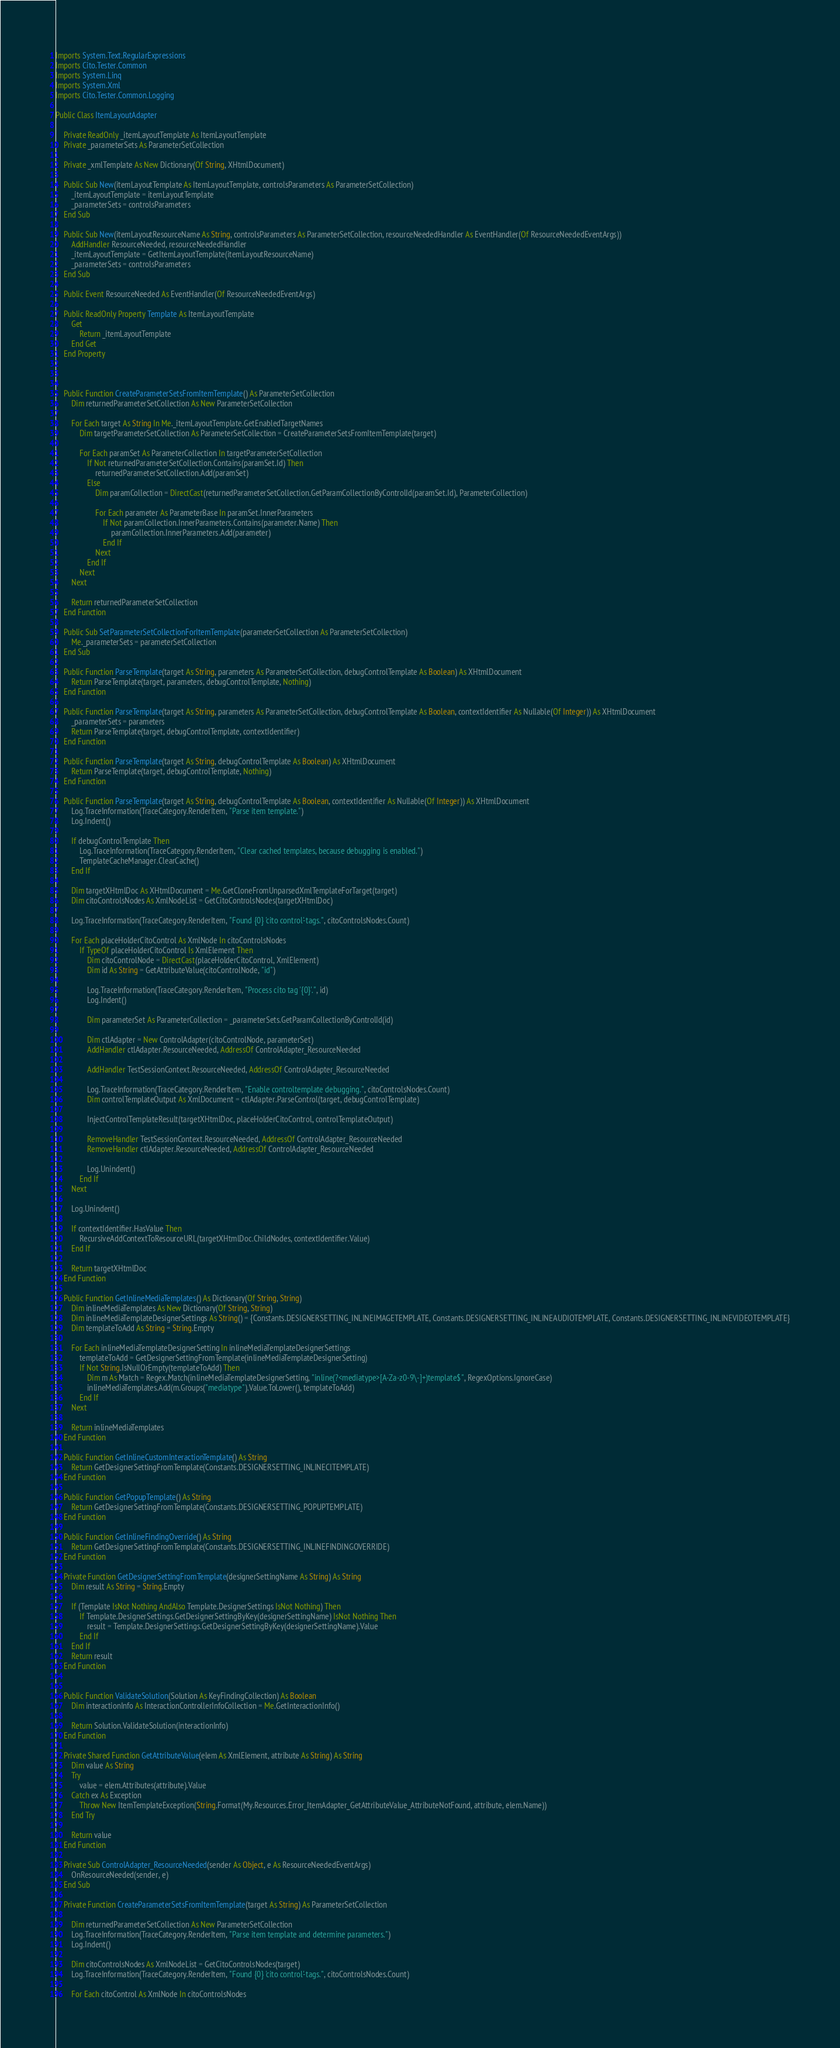Convert code to text. <code><loc_0><loc_0><loc_500><loc_500><_VisualBasic_>Imports System.Text.RegularExpressions
Imports Cito.Tester.Common
Imports System.Linq
Imports System.Xml
Imports Cito.Tester.Common.Logging

Public Class ItemLayoutAdapter

    Private ReadOnly _itemLayoutTemplate As ItemLayoutTemplate
    Private _parameterSets As ParameterSetCollection

    Private _xmlTemplate As New Dictionary(Of String, XHtmlDocument)

    Public Sub New(itemLayoutTemplate As ItemLayoutTemplate, controlsParameters As ParameterSetCollection)
        _itemLayoutTemplate = itemLayoutTemplate
        _parameterSets = controlsParameters
    End Sub

    Public Sub New(itemLayoutResourceName As String, controlsParameters As ParameterSetCollection, resourceNeededHandler As EventHandler(Of ResourceNeededEventArgs))
        AddHandler ResourceNeeded, resourceNeededHandler
        _itemLayoutTemplate = GetItemLayoutTemplate(itemLayoutResourceName)
        _parameterSets = controlsParameters
    End Sub

    Public Event ResourceNeeded As EventHandler(Of ResourceNeededEventArgs)

    Public ReadOnly Property Template As ItemLayoutTemplate
        Get
            Return _itemLayoutTemplate
        End Get
    End Property



    Public Function CreateParameterSetsFromItemTemplate() As ParameterSetCollection
        Dim returnedParameterSetCollection As New ParameterSetCollection

        For Each target As String In Me._itemLayoutTemplate.GetEnabledTargetNames
            Dim targetParameterSetCollection As ParameterSetCollection = CreateParameterSetsFromItemTemplate(target)

            For Each paramSet As ParameterCollection In targetParameterSetCollection
                If Not returnedParameterSetCollection.Contains(paramSet.Id) Then
                    returnedParameterSetCollection.Add(paramSet)
                Else
                    Dim paramCollection = DirectCast(returnedParameterSetCollection.GetParamCollectionByControlId(paramSet.Id), ParameterCollection)

                    For Each parameter As ParameterBase In paramSet.InnerParameters
                        If Not paramCollection.InnerParameters.Contains(parameter.Name) Then
                            paramCollection.InnerParameters.Add(parameter)
                        End If
                    Next
                End If
            Next
        Next

        Return returnedParameterSetCollection
    End Function

    Public Sub SetParameterSetCollectionForItemTemplate(parameterSetCollection As ParameterSetCollection)
        Me._parameterSets = parameterSetCollection
    End Sub

    Public Function ParseTemplate(target As String, parameters As ParameterSetCollection, debugControlTemplate As Boolean) As XHtmlDocument
        Return ParseTemplate(target, parameters, debugControlTemplate, Nothing)
    End Function

    Public Function ParseTemplate(target As String, parameters As ParameterSetCollection, debugControlTemplate As Boolean, contextIdentifier As Nullable(Of Integer)) As XHtmlDocument
        _parameterSets = parameters
        Return ParseTemplate(target, debugControlTemplate, contextIdentifier)
    End Function

    Public Function ParseTemplate(target As String, debugControlTemplate As Boolean) As XHtmlDocument
        Return ParseTemplate(target, debugControlTemplate, Nothing)
    End Function

    Public Function ParseTemplate(target As String, debugControlTemplate As Boolean, contextIdentifier As Nullable(Of Integer)) As XHtmlDocument
        Log.TraceInformation(TraceCategory.RenderItem, "Parse item template.")
        Log.Indent()

        If debugControlTemplate Then
            Log.TraceInformation(TraceCategory.RenderItem, "Clear cached templates, because debugging is enabled.")
            TemplateCacheManager.ClearCache()
        End If

        Dim targetXHtmlDoc As XHtmlDocument = Me.GetCloneFromUnparsedXmlTemplateForTarget(target)
        Dim citoControlsNodes As XmlNodeList = GetCitoControlsNodes(targetXHtmlDoc)

        Log.TraceInformation(TraceCategory.RenderItem, "Found {0} 'cito control'-tags.", citoControlsNodes.Count)

        For Each placeHolderCitoControl As XmlNode In citoControlsNodes
            If TypeOf placeHolderCitoControl Is XmlElement Then
                Dim citoControlNode = DirectCast(placeHolderCitoControl, XmlElement)
                Dim id As String = GetAttributeValue(citoControlNode, "id")

                Log.TraceInformation(TraceCategory.RenderItem, "Process cito tag '{0}'.", id)
                Log.Indent()

                Dim parameterSet As ParameterCollection = _parameterSets.GetParamCollectionByControlId(id)

                Dim ctlAdapter = New ControlAdapter(citoControlNode, parameterSet)
                AddHandler ctlAdapter.ResourceNeeded, AddressOf ControlAdapter_ResourceNeeded

                AddHandler TestSessionContext.ResourceNeeded, AddressOf ControlAdapter_ResourceNeeded

                Log.TraceInformation(TraceCategory.RenderItem, "Enable controltemplate debugging.", citoControlsNodes.Count)
                Dim controlTemplateOutput As XmlDocument = ctlAdapter.ParseControl(target, debugControlTemplate)

                InjectControlTemplateResult(targetXHtmlDoc, placeHolderCitoControl, controlTemplateOutput)

                RemoveHandler TestSessionContext.ResourceNeeded, AddressOf ControlAdapter_ResourceNeeded
                RemoveHandler ctlAdapter.ResourceNeeded, AddressOf ControlAdapter_ResourceNeeded

                Log.Unindent()
            End If
        Next

        Log.Unindent()

        If contextIdentifier.HasValue Then
            RecursiveAddContextToResourceURL(targetXHtmlDoc.ChildNodes, contextIdentifier.Value)
        End If

        Return targetXHtmlDoc
    End Function

    Public Function GetInlineMediaTemplates() As Dictionary(Of String, String)
        Dim inlineMediaTemplates As New Dictionary(Of String, String)
        Dim inlineMediaTemplateDesignerSettings As String() = {Constants.DESIGNERSETTING_INLINEIMAGETEMPLATE, Constants.DESIGNERSETTING_INLINEAUDIOTEMPLATE, Constants.DESIGNERSETTING_INLINEVIDEOTEMPLATE}
        Dim templateToAdd As String = String.Empty

        For Each inlineMediaTemplateDesignerSetting In inlineMediaTemplateDesignerSettings
            templateToAdd = GetDesignerSettingFromTemplate(inlineMediaTemplateDesignerSetting)
            If Not String.IsNullOrEmpty(templateToAdd) Then
                Dim m As Match = Regex.Match(inlineMediaTemplateDesignerSetting, "inline(?<mediatype>[A-Za-z0-9\-]+)template$", RegexOptions.IgnoreCase)
                inlineMediaTemplates.Add(m.Groups("mediatype").Value.ToLower(), templateToAdd)
            End If
        Next

        Return inlineMediaTemplates
    End Function

    Public Function GetInlineCustomInteractionTemplate() As String
        Return GetDesignerSettingFromTemplate(Constants.DESIGNERSETTING_INLINECITEMPLATE)
    End Function

    Public Function GetPopupTemplate() As String
        Return GetDesignerSettingFromTemplate(Constants.DESIGNERSETTING_POPUPTEMPLATE)
    End Function

    Public Function GetInlineFindingOverride() As String
        Return GetDesignerSettingFromTemplate(Constants.DESIGNERSETTING_INLINEFINDINGOVERRIDE)
    End Function

    Private Function GetDesignerSettingFromTemplate(designerSettingName As String) As String
        Dim result As String = String.Empty

        If (Template IsNot Nothing AndAlso Template.DesignerSettings IsNot Nothing) Then
            If Template.DesignerSettings.GetDesignerSettingByKey(designerSettingName) IsNot Nothing Then
                result = Template.DesignerSettings.GetDesignerSettingByKey(designerSettingName).Value
            End If
        End If
        Return result
    End Function


    Public Function ValidateSolution(Solution As KeyFindingCollection) As Boolean
        Dim interactionInfo As InteractionControllerInfoCollection = Me.GetInteractionInfo()

        Return Solution.ValidateSolution(interactionInfo)
    End Function

    Private Shared Function GetAttributeValue(elem As XmlElement, attribute As String) As String
        Dim value As String
        Try
            value = elem.Attributes(attribute).Value
        Catch ex As Exception
            Throw New ItemTemplateException(String.Format(My.Resources.Error_ItemAdapter_GetAttributeValue_AttributeNotFound, attribute, elem.Name))
        End Try

        Return value
    End Function

    Private Sub ControlAdapter_ResourceNeeded(sender As Object, e As ResourceNeededEventArgs)
        OnResourceNeeded(sender, e)
    End Sub

    Private Function CreateParameterSetsFromItemTemplate(target As String) As ParameterSetCollection

        Dim returnedParameterSetCollection As New ParameterSetCollection
        Log.TraceInformation(TraceCategory.RenderItem, "Parse item template and determine parameters.")
        Log.Indent()

        Dim citoControlsNodes As XmlNodeList = GetCitoControlsNodes(target)
        Log.TraceInformation(TraceCategory.RenderItem, "Found {0} 'cito control'-tags.", citoControlsNodes.Count)

        For Each citoControl As XmlNode In citoControlsNodes</code> 